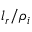Convert formula to latex. <formula><loc_0><loc_0><loc_500><loc_500>l _ { r } / \rho _ { i }</formula> 